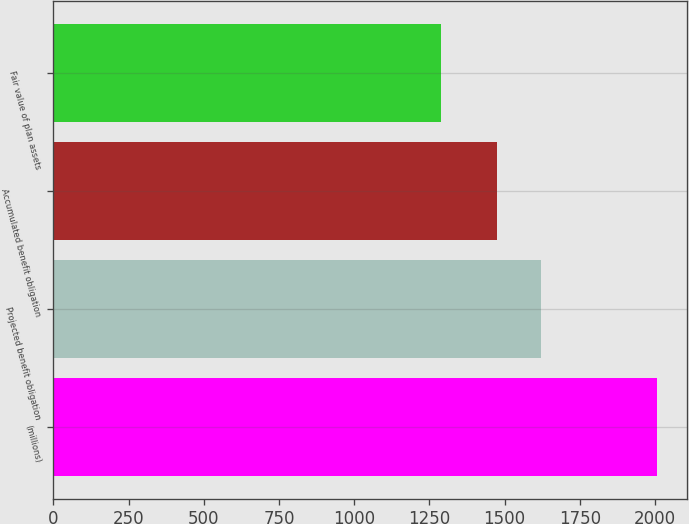<chart> <loc_0><loc_0><loc_500><loc_500><bar_chart><fcel>(millions)<fcel>Projected benefit obligation<fcel>Accumulated benefit obligation<fcel>Fair value of plan assets<nl><fcel>2005<fcel>1621.4<fcel>1473.7<fcel>1289.1<nl></chart> 